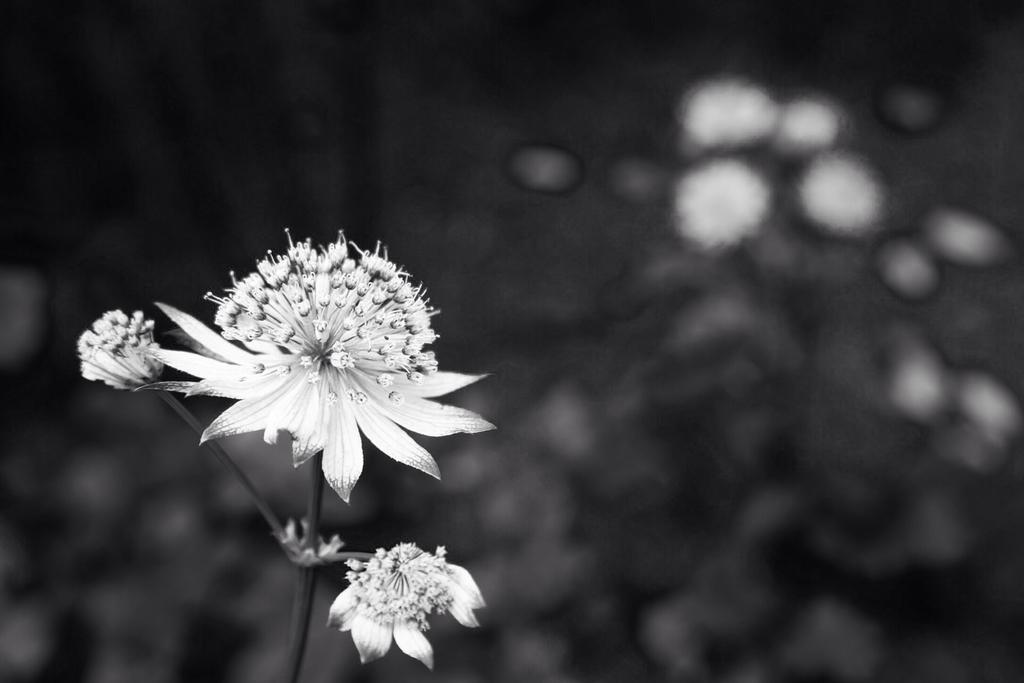What type of plants can be seen in the image? There are plants with flowers in the image. Can you describe the background of the image? The background of the image is blurred. Where is the daughter sitting in the image? There is no daughter present in the image; it only features plants with flowers and a blurred background. What type of sea creature can be seen swimming in the image? There are no sea creatures, such as jellyfish, present in the image. 